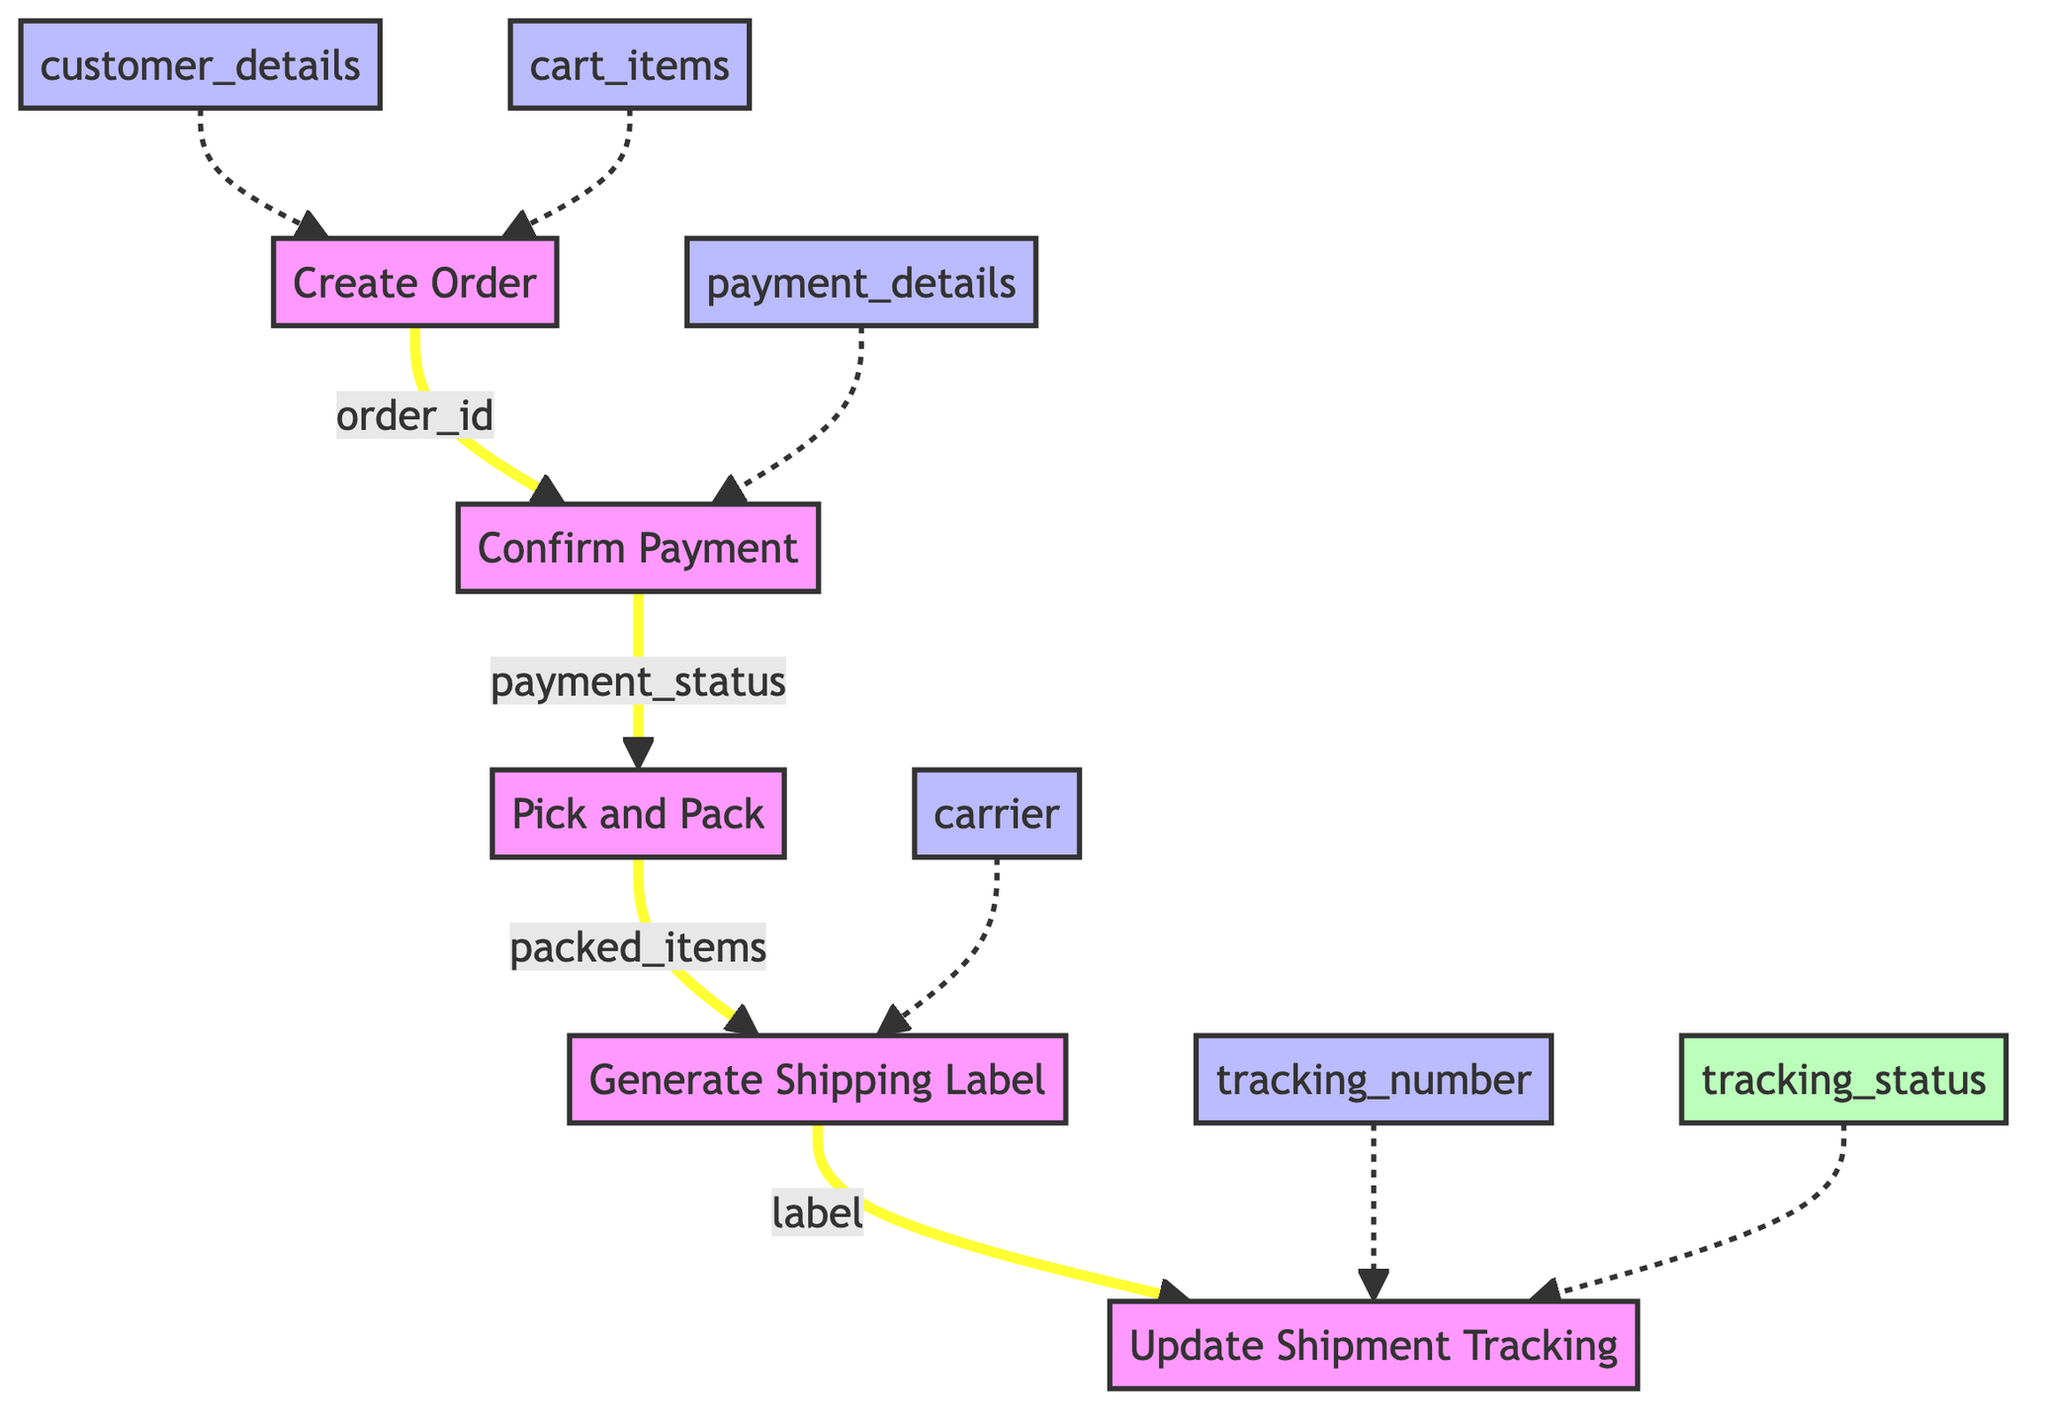What is the first function in the order fulfillment pipeline? The first function is represented at the bottom of the flowchart, which is "create order."
Answer: create order How many functions are depicted in the diagram? By counting the number of distinct functions listed in the diagram, there are five functions.
Answer: five What input is required for the "confirm payment" function? The input node directly connected to the "confirm payment" function shows that it requires "payment_details."
Answer: payment details Which function comes after "pick and pack"? Observing the flow from the "pick and pack" function, the next function connected is "generate shipping label."
Answer: generate shipping label What is the output of the "update shipment tracking" function? The output from the "update shipment tracking" function shows it outputs a "tracking_status."
Answer: tracking status What is the relationship between "create order" and "confirm payment"? The flow indicates that the output of "create order" provides the input "order_id" to the "confirm payment" function, establishing a direct relationship.
Answer: order_id How many inputs does the "generate shipping label" function have? The input for the "generate shipping label" function includes one input labeled "carrier," in addition to "order_id." Thus, it has two inputs.
Answer: two inputs Which output is provided by the "confirm payment" function? The flowchart shows that the "confirm payment" function outputs "payment_status" as its result.
Answer: payment status What is the second function in the order fulfillment pipeline? The functions are connected in a sequence; the second function after "create order" is "confirm payment."
Answer: confirm payment 